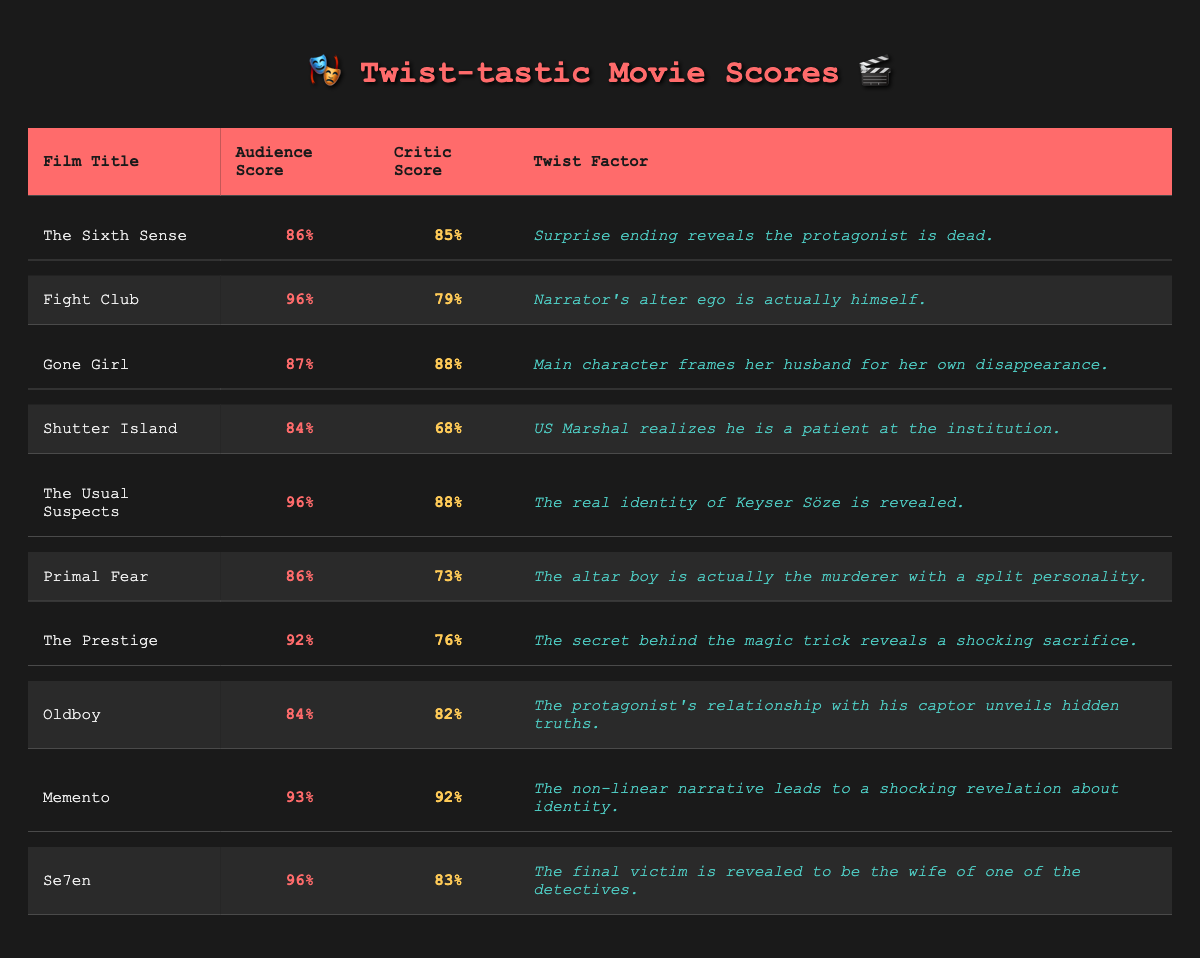What is the highest audience score among the films? The table lists the audience scores for each film. Scanning through these, "Fight Club" has the highest score of 96%.
Answer: 96% Which film has the lowest critic score? From the critic scores in the table, "Shutter Island" has the lowest score of 68%.
Answer: 68% What is the difference between the audience score and the critic score for "Gone Girl"? The audience score for "Gone Girl" is 87%, and the critic score is 88%. The difference is 88 - 87 = 1.
Answer: 1 Which film has the highest audience score and what is its twist factor? "Fight Club" has the highest audience score of 96%, and its twist factor is that the narrator's alter ego is actually himself.
Answer: Fight Club: Narrator's alter ego is himself Are there any films where the audience score is higher than the critic score? By reviewing the scores, "Fight Club," "The Usual Suspects," and "Primal Fear" all have higher audience scores than critic scores, confirming the statement as true.
Answer: Yes What is the average audience score for all the films listed? To find the average, sum all the audience scores: 86 + 96 + 87 + 84 + 96 + 86 + 92 + 84 + 93 + 96 =  81.3. Then, divide by the number of films (10): 870/10 = 87.
Answer: 87 Which film with a twist factor involving identity has the highest audience score? "Memento" has a twist related to identity and has an audience score of 93%, which is the highest among the films with twist factors involving identity.
Answer: Memento What is the overall perception of "The Prestige" compared to "Shutter Island" based on audience and critic scores? "The Prestige" has a higher audience score (92% vs. 84%) and critic score (76% vs. 68%), indicating it is perceived more favorably by both audiences and critics than "Shutter Island."
Answer: "The Prestige" is perceived more favorably How many films have audience scores above 90%? By counting in the table, there are four films with audience scores above 90%: "Fight Club," "The Usual Suspects," "Memento," and "The Prestige."
Answer: 4 What is the average critic score for films with a twist factor related to deception or surprise? The relevant films with such twists include "The Sixth Sense," "Gone Girl," "Shutter Island," "The Prestige," and "Se7en." Adding the critic scores (85 + 88 + 68 + 76 + 83) gives 400. Dividing by 5 films gives an average of 80.
Answer: 80 